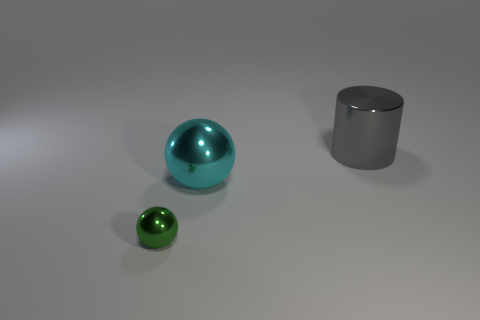Add 2 small green balls. How many objects exist? 5 Subtract all spheres. How many objects are left? 1 Add 1 cyan metal balls. How many cyan metal balls exist? 2 Subtract 0 yellow spheres. How many objects are left? 3 Subtract all green cylinders. Subtract all cylinders. How many objects are left? 2 Add 1 cyan shiny things. How many cyan shiny things are left? 2 